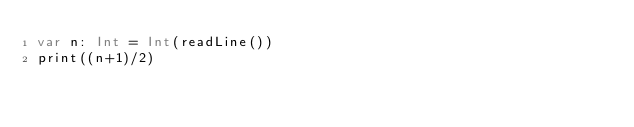<code> <loc_0><loc_0><loc_500><loc_500><_Swift_>var n: Int = Int(readLine())
print((n+1)/2)</code> 